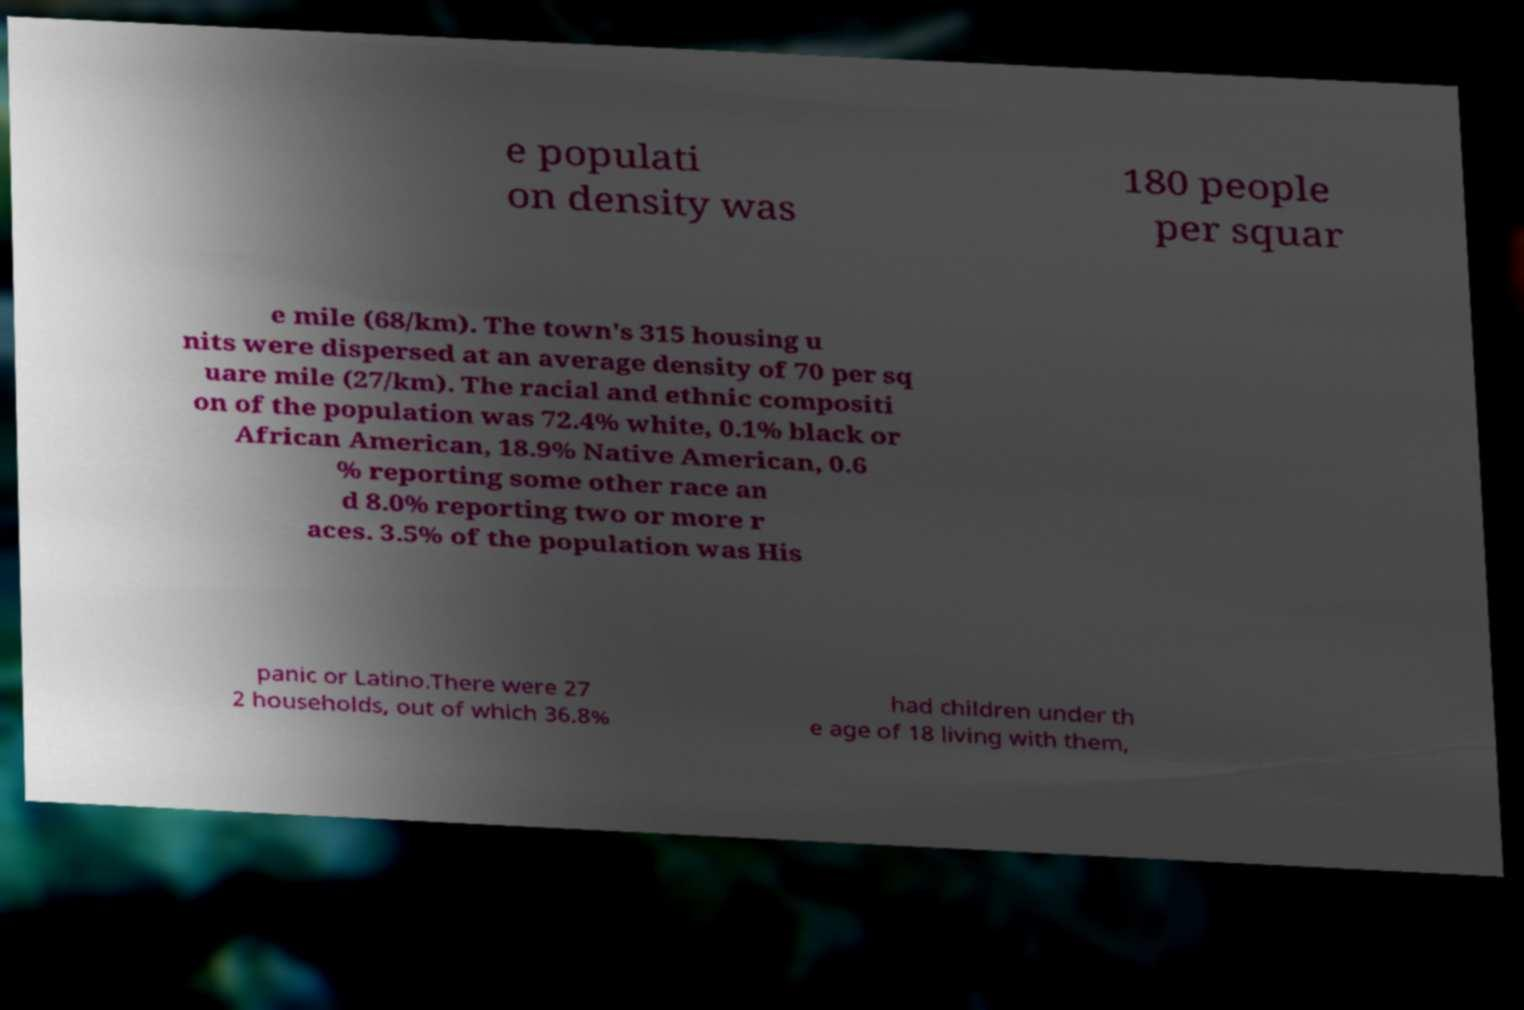Could you extract and type out the text from this image? e populati on density was 180 people per squar e mile (68/km). The town's 315 housing u nits were dispersed at an average density of 70 per sq uare mile (27/km). The racial and ethnic compositi on of the population was 72.4% white, 0.1% black or African American, 18.9% Native American, 0.6 % reporting some other race an d 8.0% reporting two or more r aces. 3.5% of the population was His panic or Latino.There were 27 2 households, out of which 36.8% had children under th e age of 18 living with them, 